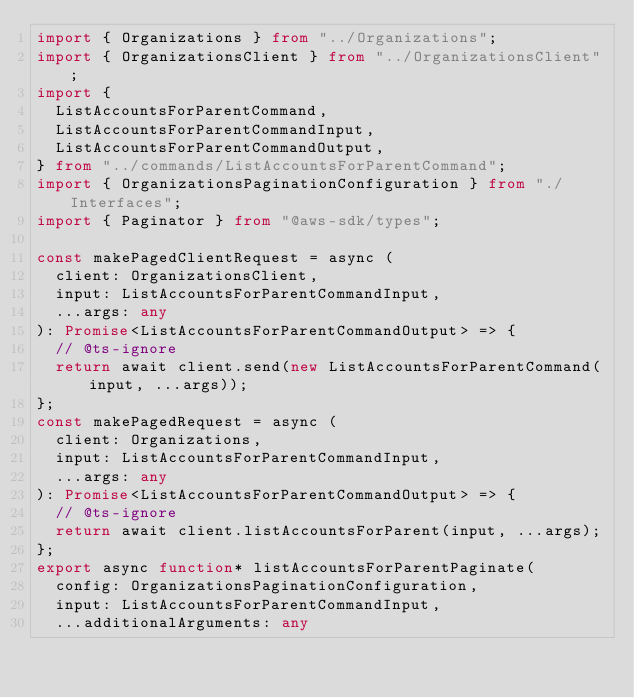<code> <loc_0><loc_0><loc_500><loc_500><_TypeScript_>import { Organizations } from "../Organizations";
import { OrganizationsClient } from "../OrganizationsClient";
import {
  ListAccountsForParentCommand,
  ListAccountsForParentCommandInput,
  ListAccountsForParentCommandOutput,
} from "../commands/ListAccountsForParentCommand";
import { OrganizationsPaginationConfiguration } from "./Interfaces";
import { Paginator } from "@aws-sdk/types";

const makePagedClientRequest = async (
  client: OrganizationsClient,
  input: ListAccountsForParentCommandInput,
  ...args: any
): Promise<ListAccountsForParentCommandOutput> => {
  // @ts-ignore
  return await client.send(new ListAccountsForParentCommand(input, ...args));
};
const makePagedRequest = async (
  client: Organizations,
  input: ListAccountsForParentCommandInput,
  ...args: any
): Promise<ListAccountsForParentCommandOutput> => {
  // @ts-ignore
  return await client.listAccountsForParent(input, ...args);
};
export async function* listAccountsForParentPaginate(
  config: OrganizationsPaginationConfiguration,
  input: ListAccountsForParentCommandInput,
  ...additionalArguments: any</code> 